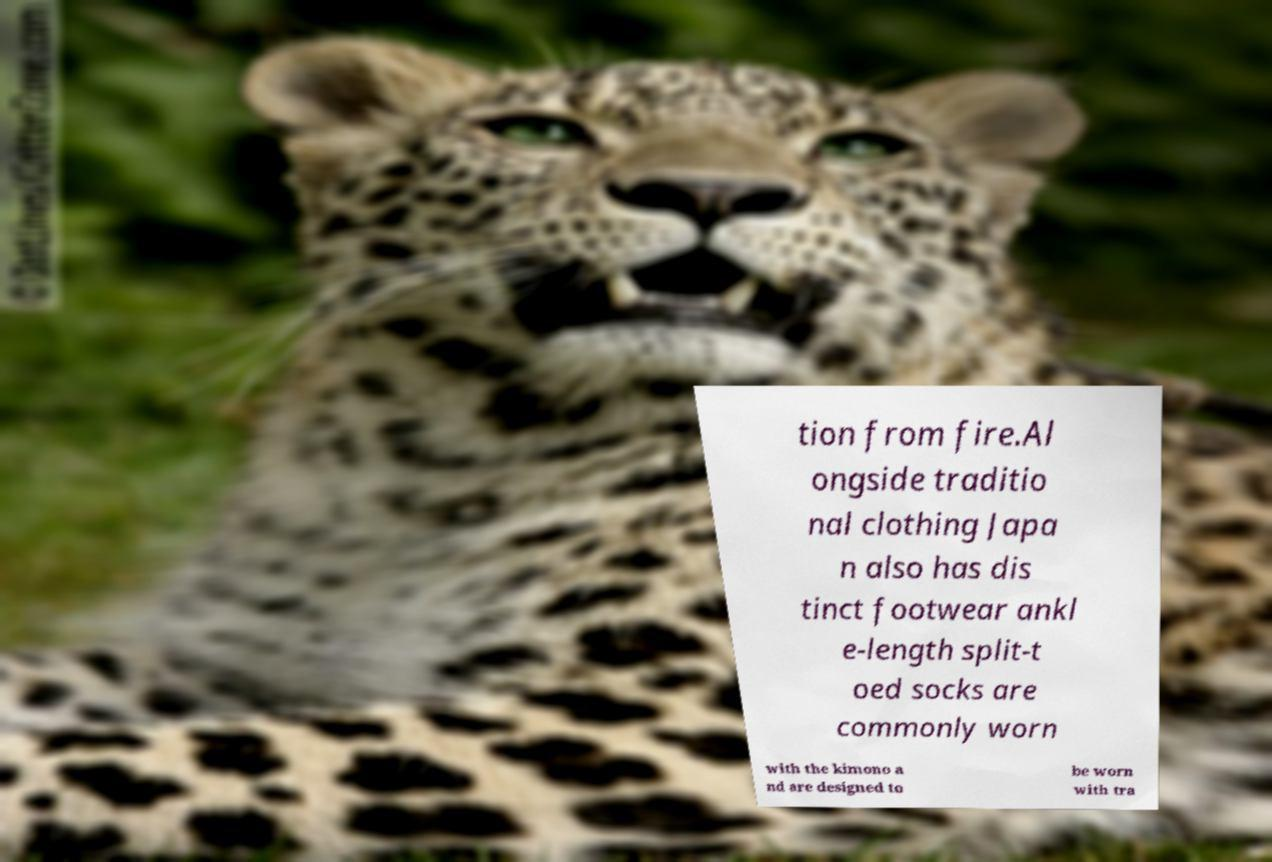Could you assist in decoding the text presented in this image and type it out clearly? tion from fire.Al ongside traditio nal clothing Japa n also has dis tinct footwear ankl e-length split-t oed socks are commonly worn with the kimono a nd are designed to be worn with tra 